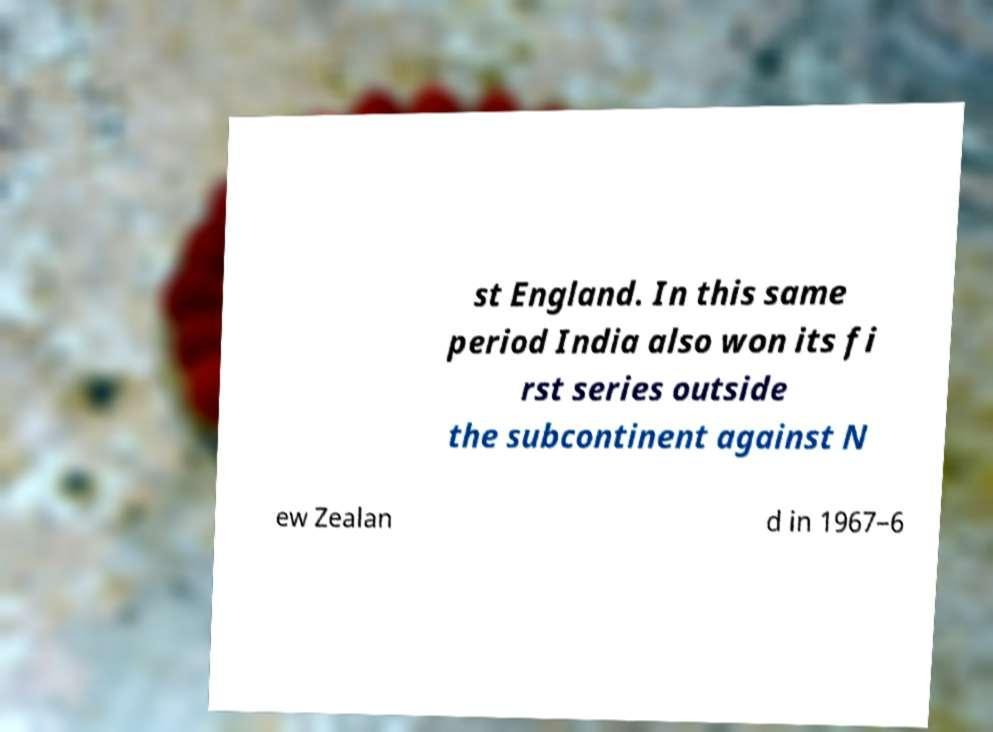Can you read and provide the text displayed in the image?This photo seems to have some interesting text. Can you extract and type it out for me? st England. In this same period India also won its fi rst series outside the subcontinent against N ew Zealan d in 1967–6 